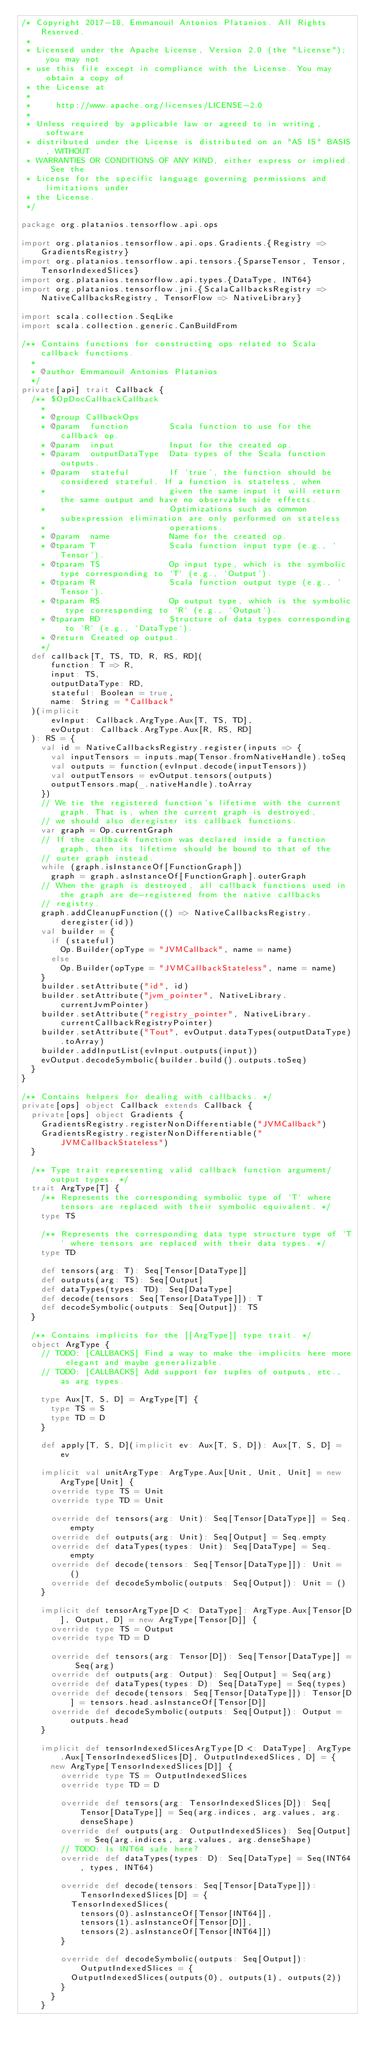<code> <loc_0><loc_0><loc_500><loc_500><_Scala_>/* Copyright 2017-18, Emmanouil Antonios Platanios. All Rights Reserved.
 *
 * Licensed under the Apache License, Version 2.0 (the "License"); you may not
 * use this file except in compliance with the License. You may obtain a copy of
 * the License at
 *
 *     http://www.apache.org/licenses/LICENSE-2.0
 *
 * Unless required by applicable law or agreed to in writing, software
 * distributed under the License is distributed on an "AS IS" BASIS, WITHOUT
 * WARRANTIES OR CONDITIONS OF ANY KIND, either express or implied. See the
 * License for the specific language governing permissions and limitations under
 * the License.
 */

package org.platanios.tensorflow.api.ops

import org.platanios.tensorflow.api.ops.Gradients.{Registry => GradientsRegistry}
import org.platanios.tensorflow.api.tensors.{SparseTensor, Tensor, TensorIndexedSlices}
import org.platanios.tensorflow.api.types.{DataType, INT64}
import org.platanios.tensorflow.jni.{ScalaCallbacksRegistry => NativeCallbacksRegistry, TensorFlow => NativeLibrary}

import scala.collection.SeqLike
import scala.collection.generic.CanBuildFrom

/** Contains functions for constructing ops related to Scala callback functions.
  *
  * @author Emmanouil Antonios Platanios
  */
private[api] trait Callback {
  /** $OpDocCallbackCallback
    *
    * @group CallbackOps
    * @param  function        Scala function to use for the callback op.
    * @param  input           Input for the created op.
    * @param  outputDataType  Data types of the Scala function outputs.
    * @param  stateful        If `true`, the function should be considered stateful. If a function is stateless, when
    *                         given the same input it will return the same output and have no observable side effects.
    *                         Optimizations such as common subexpression elimination are only performed on stateless
    *                         operations.
    * @param  name            Name for the created op.
    * @tparam T               Scala function input type (e.g., `Tensor`).
    * @tparam TS              Op input type, which is the symbolic type corresponding to `T` (e.g., `Output`).
    * @tparam R               Scala function output type (e.g., `Tensor`).
    * @tparam RS              Op output type, which is the symbolic type corresponding to `R` (e.g., `Output`).
    * @tparam RD              Structure of data types corresponding to `R` (e.g., `DataType`).
    * @return Created op output.
    */
  def callback[T, TS, TD, R, RS, RD](
      function: T => R,
      input: TS,
      outputDataType: RD,
      stateful: Boolean = true,
      name: String = "Callback"
  )(implicit
      evInput: Callback.ArgType.Aux[T, TS, TD],
      evOutput: Callback.ArgType.Aux[R, RS, RD]
  ): RS = {
    val id = NativeCallbacksRegistry.register(inputs => {
      val inputTensors = inputs.map(Tensor.fromNativeHandle).toSeq
      val outputs = function(evInput.decode(inputTensors))
      val outputTensors = evOutput.tensors(outputs)
      outputTensors.map(_.nativeHandle).toArray
    })
    // We tie the registered function's lifetime with the current graph. That is, when the current graph is destroyed,
    // we should also deregister its callback functions.
    var graph = Op.currentGraph
    // If the callback function was declared inside a function graph, then its lifetime should be bound to that of the
    // outer graph instead.
    while (graph.isInstanceOf[FunctionGraph])
      graph = graph.asInstanceOf[FunctionGraph].outerGraph
    // When the graph is destroyed, all callback functions used in the graph are de-registered from the native callbacks
    // registry.
    graph.addCleanupFunction(() => NativeCallbacksRegistry.deregister(id))
    val builder = {
      if (stateful)
        Op.Builder(opType = "JVMCallback", name = name)
      else
        Op.Builder(opType = "JVMCallbackStateless", name = name)
    }
    builder.setAttribute("id", id)
    builder.setAttribute("jvm_pointer", NativeLibrary.currentJvmPointer)
    builder.setAttribute("registry_pointer", NativeLibrary.currentCallbackRegistryPointer)
    builder.setAttribute("Tout", evOutput.dataTypes(outputDataType).toArray)
    builder.addInputList(evInput.outputs(input))
    evOutput.decodeSymbolic(builder.build().outputs.toSeq)
  }
}

/** Contains helpers for dealing with callbacks. */
private[ops] object Callback extends Callback {
  private[ops] object Gradients {
    GradientsRegistry.registerNonDifferentiable("JVMCallback")
    GradientsRegistry.registerNonDifferentiable("JVMCallbackStateless")
  }

  /** Type trait representing valid callback function argument/output types. */
  trait ArgType[T] {
    /** Represents the corresponding symbolic type of `T` where tensors are replaced with their symbolic equivalent. */
    type TS

    /** Represents the corresponding data type structure type of `T` where tensors are replaced with their data types. */
    type TD

    def tensors(arg: T): Seq[Tensor[DataType]]
    def outputs(arg: TS): Seq[Output]
    def dataTypes(types: TD): Seq[DataType]
    def decode(tensors: Seq[Tensor[DataType]]): T
    def decodeSymbolic(outputs: Seq[Output]): TS
  }

  /** Contains implicits for the [[ArgType]] type trait. */
  object ArgType {
    // TODO: [CALLBACKS] Find a way to make the implicits here more elegant and maybe generalizable.
    // TODO: [CALLBACKS] Add support for tuples of outputs, etc., as arg types.

    type Aux[T, S, D] = ArgType[T] {
      type TS = S
      type TD = D
    }

    def apply[T, S, D](implicit ev: Aux[T, S, D]): Aux[T, S, D] = ev

    implicit val unitArgType: ArgType.Aux[Unit, Unit, Unit] = new ArgType[Unit] {
      override type TS = Unit
      override type TD = Unit

      override def tensors(arg: Unit): Seq[Tensor[DataType]] = Seq.empty
      override def outputs(arg: Unit): Seq[Output] = Seq.empty
      override def dataTypes(types: Unit): Seq[DataType] = Seq.empty
      override def decode(tensors: Seq[Tensor[DataType]]): Unit = ()
      override def decodeSymbolic(outputs: Seq[Output]): Unit = ()
    }

    implicit def tensorArgType[D <: DataType]: ArgType.Aux[Tensor[D], Output, D] = new ArgType[Tensor[D]] {
      override type TS = Output
      override type TD = D

      override def tensors(arg: Tensor[D]): Seq[Tensor[DataType]] = Seq(arg)
      override def outputs(arg: Output): Seq[Output] = Seq(arg)
      override def dataTypes(types: D): Seq[DataType] = Seq(types)
      override def decode(tensors: Seq[Tensor[DataType]]): Tensor[D] = tensors.head.asInstanceOf[Tensor[D]]
      override def decodeSymbolic(outputs: Seq[Output]): Output = outputs.head
    }

    implicit def tensorIndexedSlicesArgType[D <: DataType]: ArgType.Aux[TensorIndexedSlices[D], OutputIndexedSlices, D] = {
      new ArgType[TensorIndexedSlices[D]] {
        override type TS = OutputIndexedSlices
        override type TD = D

        override def tensors(arg: TensorIndexedSlices[D]): Seq[Tensor[DataType]] = Seq(arg.indices, arg.values, arg.denseShape)
        override def outputs(arg: OutputIndexedSlices): Seq[Output] = Seq(arg.indices, arg.values, arg.denseShape)
        // TODO: Is INT64 safe here?
        override def dataTypes(types: D): Seq[DataType] = Seq(INT64, types, INT64)

        override def decode(tensors: Seq[Tensor[DataType]]): TensorIndexedSlices[D] = {
          TensorIndexedSlices(
            tensors(0).asInstanceOf[Tensor[INT64]],
            tensors(1).asInstanceOf[Tensor[D]],
            tensors(2).asInstanceOf[Tensor[INT64]])
        }

        override def decodeSymbolic(outputs: Seq[Output]): OutputIndexedSlices = {
          OutputIndexedSlices(outputs(0), outputs(1), outputs(2))
        }
      }
    }
</code> 